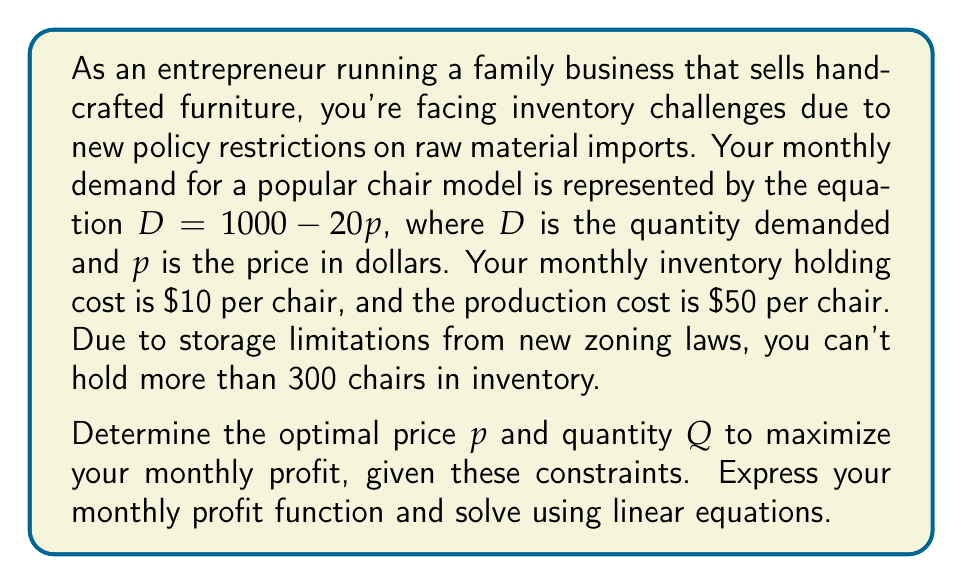Teach me how to tackle this problem. Let's approach this step-by-step:

1) First, we need to express the quantity $Q$ in terms of price $p$:
   $Q = 1000 - 20p$ (since at equilibrium, quantity supplied equals quantity demanded)

2) The profit function $\Pi$ is given by:
   $\Pi = \text{Revenue} - \text{Production Cost} - \text{Holding Cost}$
   $\Pi = pQ - 50Q - 10Q$
   $\Pi = p(1000 - 20p) - 60(1000 - 20p)$
   $\Pi = 1000p - 20p^2 - 60000 + 1200p$
   $\Pi = -20p^2 + 2200p - 60000$

3) To maximize profit, we differentiate $\Pi$ with respect to $p$ and set it to zero:
   $\frac{d\Pi}{dp} = -40p + 2200 = 0$
   $40p = 2200$
   $p = 55$

4) The second derivative $\frac{d^2\Pi}{dp^2} = -40 < 0$, confirming this is a maximum.

5) At $p = 55$, $Q = 1000 - 20(55) = 1000 - 1100 = -100$

   However, $Q$ cannot be negative. This means our constraint of 300 chairs maximum is binding.

6) With the constraint $Q \leq 300$, we solve:
   $300 = 1000 - 20p$
   $20p = 700$
   $p = 35$

7) Check if this satisfies the non-negativity constraint on $Q$:
   At $p = 35$, $Q = 1000 - 20(35) = 300$ (which is the maximum allowed)

8) The optimal profit is:
   $\Pi = -20(35)^2 + 2200(35) - 60000 = -24500 + 77000 - 60000 = -7500$
Answer: The optimal price is $p = \$35$ and the optimal quantity is $Q = 300$ chairs. The maximum monthly profit under these constraints is $\$-7500$, indicating a loss. 